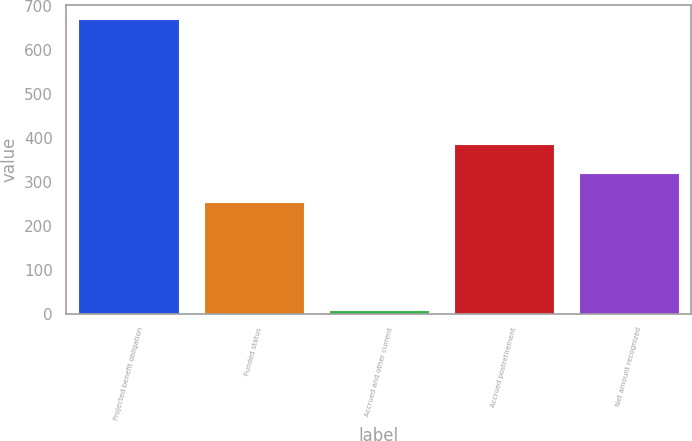Convert chart. <chart><loc_0><loc_0><loc_500><loc_500><bar_chart><fcel>Projected benefit obligation<fcel>Funded status<fcel>Accrued and other current<fcel>Accrued postretirement<fcel>Net amount recognized<nl><fcel>670<fcel>253<fcel>9<fcel>385.2<fcel>319.1<nl></chart> 